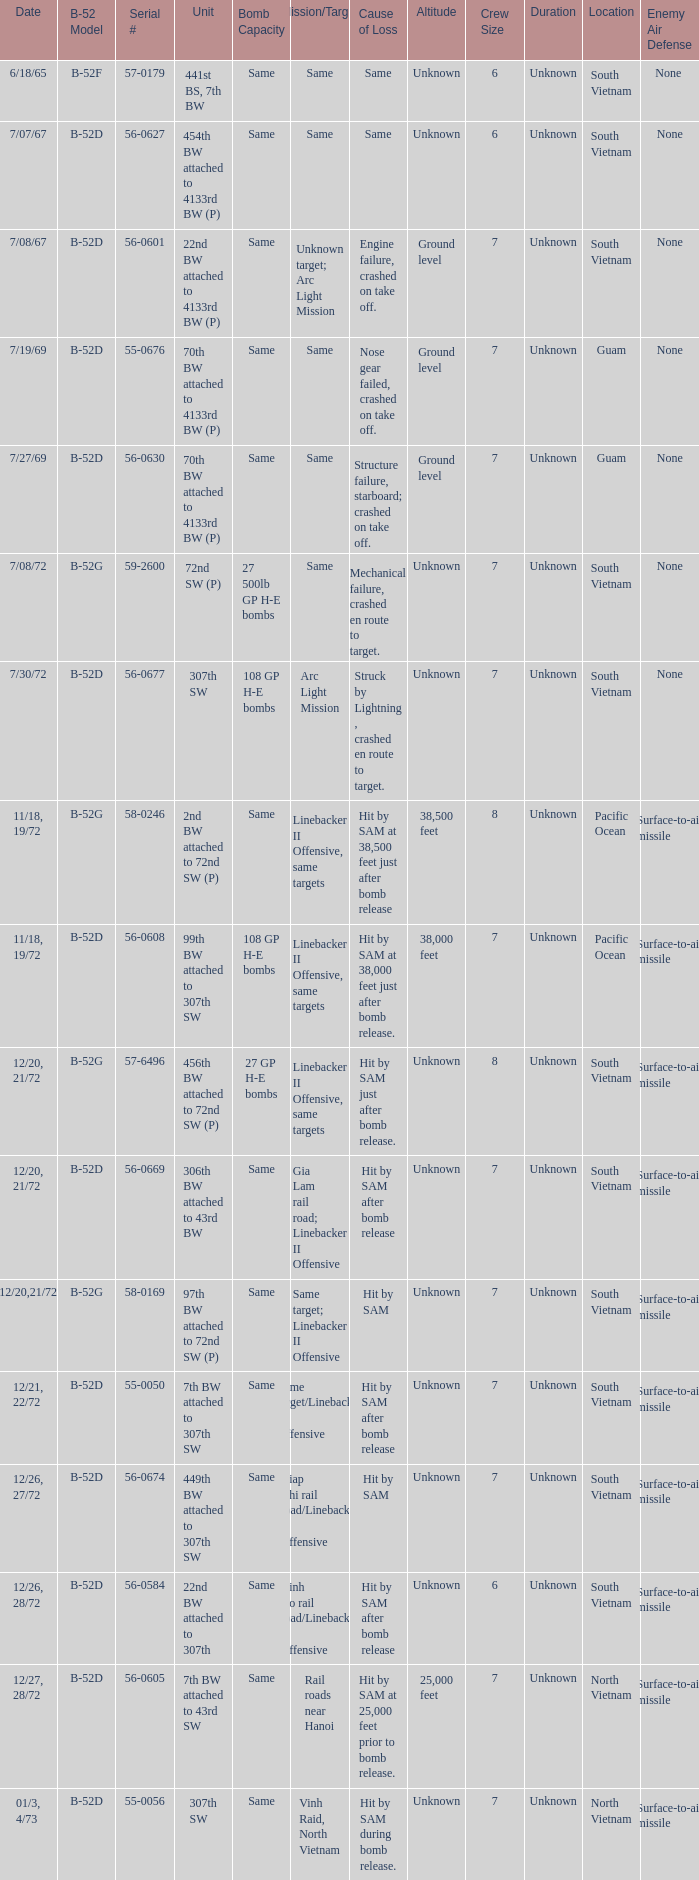When 441st bs, 7th bw is the unit what is the b-52 model? B-52F. 